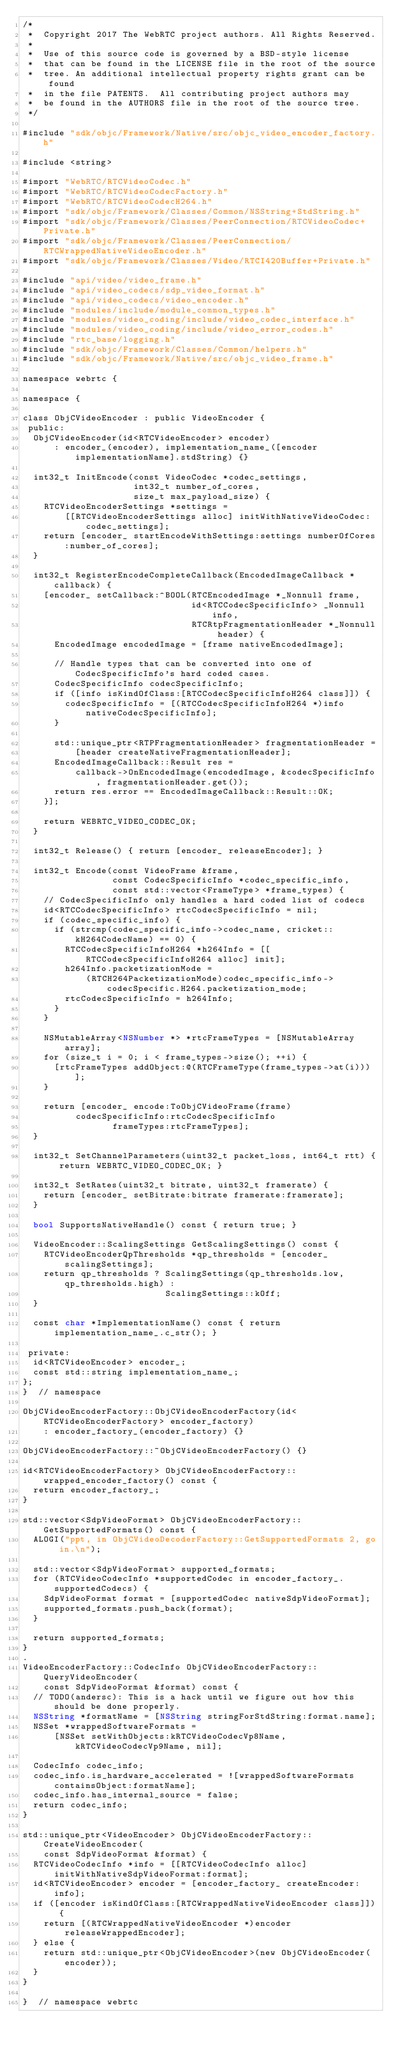<code> <loc_0><loc_0><loc_500><loc_500><_ObjectiveC_>/*
 *  Copyright 2017 The WebRTC project authors. All Rights Reserved.
 *
 *  Use of this source code is governed by a BSD-style license
 *  that can be found in the LICENSE file in the root of the source
 *  tree. An additional intellectual property rights grant can be found
 *  in the file PATENTS.  All contributing project authors may
 *  be found in the AUTHORS file in the root of the source tree.
 */

#include "sdk/objc/Framework/Native/src/objc_video_encoder_factory.h"

#include <string>

#import "WebRTC/RTCVideoCodec.h"
#import "WebRTC/RTCVideoCodecFactory.h"
#import "WebRTC/RTCVideoCodecH264.h"
#import "sdk/objc/Framework/Classes/Common/NSString+StdString.h"
#import "sdk/objc/Framework/Classes/PeerConnection/RTCVideoCodec+Private.h"
#import "sdk/objc/Framework/Classes/PeerConnection/RTCWrappedNativeVideoEncoder.h"
#import "sdk/objc/Framework/Classes/Video/RTCI420Buffer+Private.h"

#include "api/video/video_frame.h"
#include "api/video_codecs/sdp_video_format.h"
#include "api/video_codecs/video_encoder.h"
#include "modules/include/module_common_types.h"
#include "modules/video_coding/include/video_codec_interface.h"
#include "modules/video_coding/include/video_error_codes.h"
#include "rtc_base/logging.h"
#include "sdk/objc/Framework/Classes/Common/helpers.h"
#include "sdk/objc/Framework/Native/src/objc_video_frame.h"

namespace webrtc {

namespace {

class ObjCVideoEncoder : public VideoEncoder {
 public:
  ObjCVideoEncoder(id<RTCVideoEncoder> encoder)
      : encoder_(encoder), implementation_name_([encoder implementationName].stdString) {}

  int32_t InitEncode(const VideoCodec *codec_settings,
                     int32_t number_of_cores,
                     size_t max_payload_size) {
    RTCVideoEncoderSettings *settings =
        [[RTCVideoEncoderSettings alloc] initWithNativeVideoCodec:codec_settings];
    return [encoder_ startEncodeWithSettings:settings numberOfCores:number_of_cores];
  }

  int32_t RegisterEncodeCompleteCallback(EncodedImageCallback *callback) {
    [encoder_ setCallback:^BOOL(RTCEncodedImage *_Nonnull frame,
                                id<RTCCodecSpecificInfo> _Nonnull info,
                                RTCRtpFragmentationHeader *_Nonnull header) {
      EncodedImage encodedImage = [frame nativeEncodedImage];

      // Handle types that can be converted into one of CodecSpecificInfo's hard coded cases.
      CodecSpecificInfo codecSpecificInfo;
      if ([info isKindOfClass:[RTCCodecSpecificInfoH264 class]]) {
        codecSpecificInfo = [(RTCCodecSpecificInfoH264 *)info nativeCodecSpecificInfo];
      }

      std::unique_ptr<RTPFragmentationHeader> fragmentationHeader =
          [header createNativeFragmentationHeader];
      EncodedImageCallback::Result res =
          callback->OnEncodedImage(encodedImage, &codecSpecificInfo, fragmentationHeader.get());
      return res.error == EncodedImageCallback::Result::OK;
    }];

    return WEBRTC_VIDEO_CODEC_OK;
  }

  int32_t Release() { return [encoder_ releaseEncoder]; }

  int32_t Encode(const VideoFrame &frame,
                 const CodecSpecificInfo *codec_specific_info,
                 const std::vector<FrameType> *frame_types) {
    // CodecSpecificInfo only handles a hard coded list of codecs
    id<RTCCodecSpecificInfo> rtcCodecSpecificInfo = nil;
    if (codec_specific_info) {
      if (strcmp(codec_specific_info->codec_name, cricket::kH264CodecName) == 0) {
        RTCCodecSpecificInfoH264 *h264Info = [[RTCCodecSpecificInfoH264 alloc] init];
        h264Info.packetizationMode =
            (RTCH264PacketizationMode)codec_specific_info->codecSpecific.H264.packetization_mode;
        rtcCodecSpecificInfo = h264Info;
      }
    }

    NSMutableArray<NSNumber *> *rtcFrameTypes = [NSMutableArray array];
    for (size_t i = 0; i < frame_types->size(); ++i) {
      [rtcFrameTypes addObject:@(RTCFrameType(frame_types->at(i)))];
    }

    return [encoder_ encode:ToObjCVideoFrame(frame)
          codecSpecificInfo:rtcCodecSpecificInfo
                 frameTypes:rtcFrameTypes];
  }

  int32_t SetChannelParameters(uint32_t packet_loss, int64_t rtt) { return WEBRTC_VIDEO_CODEC_OK; }

  int32_t SetRates(uint32_t bitrate, uint32_t framerate) {
    return [encoder_ setBitrate:bitrate framerate:framerate];
  }

  bool SupportsNativeHandle() const { return true; }

  VideoEncoder::ScalingSettings GetScalingSettings() const {
    RTCVideoEncoderQpThresholds *qp_thresholds = [encoder_ scalingSettings];
    return qp_thresholds ? ScalingSettings(qp_thresholds.low, qp_thresholds.high) :
                           ScalingSettings::kOff;
  }

  const char *ImplementationName() const { return implementation_name_.c_str(); }

 private:
  id<RTCVideoEncoder> encoder_;
  const std::string implementation_name_;
};
}  // namespace

ObjCVideoEncoderFactory::ObjCVideoEncoderFactory(id<RTCVideoEncoderFactory> encoder_factory)
    : encoder_factory_(encoder_factory) {}

ObjCVideoEncoderFactory::~ObjCVideoEncoderFactory() {}

id<RTCVideoEncoderFactory> ObjCVideoEncoderFactory::wrapped_encoder_factory() const {
  return encoder_factory_;
}

std::vector<SdpVideoFormat> ObjCVideoEncoderFactory::GetSupportedFormats() const {
  ALOGI("ppt, in ObjCVideoDecoderFactory::GetSupportedFormats 2, go in.\n");

  std::vector<SdpVideoFormat> supported_formats;
  for (RTCVideoCodecInfo *supportedCodec in encoder_factory_.supportedCodecs) {
    SdpVideoFormat format = [supportedCodec nativeSdpVideoFormat];
    supported_formats.push_back(format);
  }

  return supported_formats;
}
.
VideoEncoderFactory::CodecInfo ObjCVideoEncoderFactory::QueryVideoEncoder(
    const SdpVideoFormat &format) const {
  // TODO(andersc): This is a hack until we figure out how this should be done properly.
  NSString *formatName = [NSString stringForStdString:format.name];
  NSSet *wrappedSoftwareFormats =
      [NSSet setWithObjects:kRTCVideoCodecVp8Name, kRTCVideoCodecVp9Name, nil];

  CodecInfo codec_info;
  codec_info.is_hardware_accelerated = ![wrappedSoftwareFormats containsObject:formatName];
  codec_info.has_internal_source = false;
  return codec_info;
}

std::unique_ptr<VideoEncoder> ObjCVideoEncoderFactory::CreateVideoEncoder(
    const SdpVideoFormat &format) {
  RTCVideoCodecInfo *info = [[RTCVideoCodecInfo alloc] initWithNativeSdpVideoFormat:format];
  id<RTCVideoEncoder> encoder = [encoder_factory_ createEncoder:info];
  if ([encoder isKindOfClass:[RTCWrappedNativeVideoEncoder class]]) {
    return [(RTCWrappedNativeVideoEncoder *)encoder releaseWrappedEncoder];
  } else {
    return std::unique_ptr<ObjCVideoEncoder>(new ObjCVideoEncoder(encoder));
  }
}

}  // namespace webrtc
</code> 